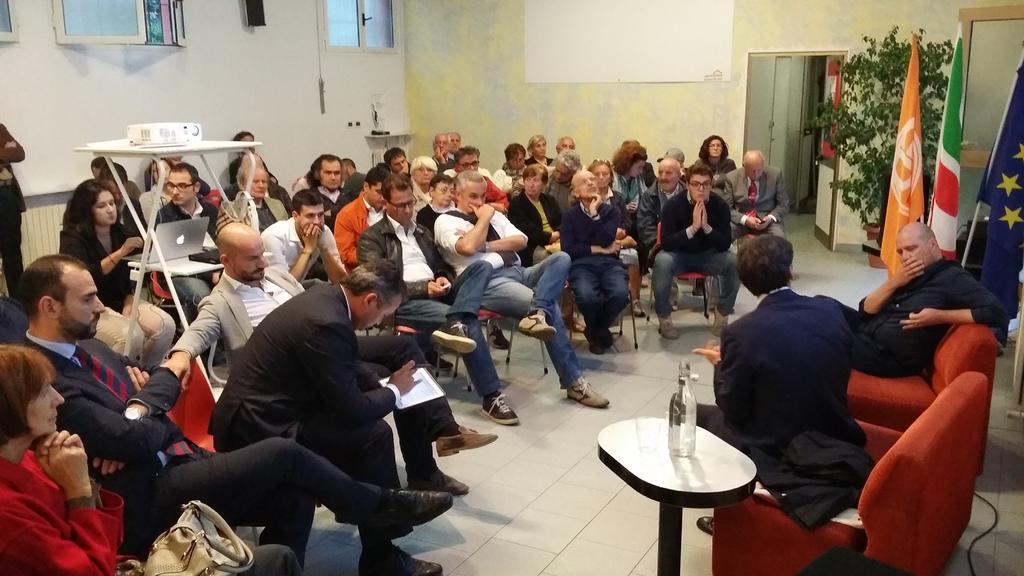Please provide a concise description of this image. This image is taken indoors. In the background there is a wall with doors and windows. In the middle of the image many people are sitting on the chairs and there is a table with a projector, a laptop and a device on it. A man is holding a tab in his hands and another man is standing on the floor. On the right side of the image there are three flags. There is a plant in the pot. Two men are sitting on the couches and there is a table with a bottle on it. 